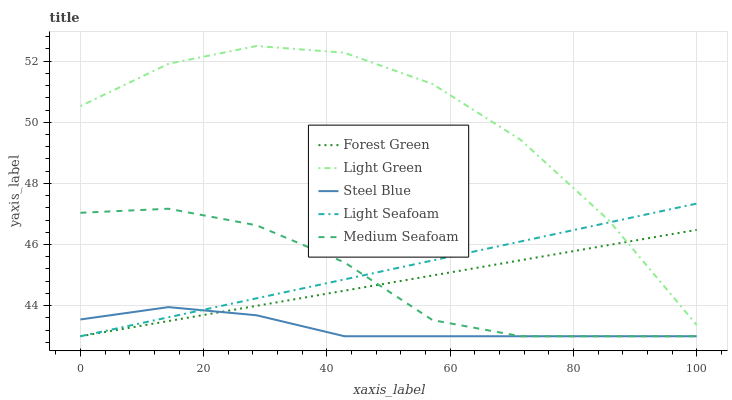Does Steel Blue have the minimum area under the curve?
Answer yes or no. Yes. Does Light Green have the maximum area under the curve?
Answer yes or no. Yes. Does Light Seafoam have the minimum area under the curve?
Answer yes or no. No. Does Light Seafoam have the maximum area under the curve?
Answer yes or no. No. Is Forest Green the smoothest?
Answer yes or no. Yes. Is Light Green the roughest?
Answer yes or no. Yes. Is Light Seafoam the smoothest?
Answer yes or no. No. Is Light Seafoam the roughest?
Answer yes or no. No. Does Forest Green have the lowest value?
Answer yes or no. Yes. Does Light Green have the lowest value?
Answer yes or no. No. Does Light Green have the highest value?
Answer yes or no. Yes. Does Light Seafoam have the highest value?
Answer yes or no. No. Is Medium Seafoam less than Light Green?
Answer yes or no. Yes. Is Light Green greater than Medium Seafoam?
Answer yes or no. Yes. Does Steel Blue intersect Light Seafoam?
Answer yes or no. Yes. Is Steel Blue less than Light Seafoam?
Answer yes or no. No. Is Steel Blue greater than Light Seafoam?
Answer yes or no. No. Does Medium Seafoam intersect Light Green?
Answer yes or no. No. 